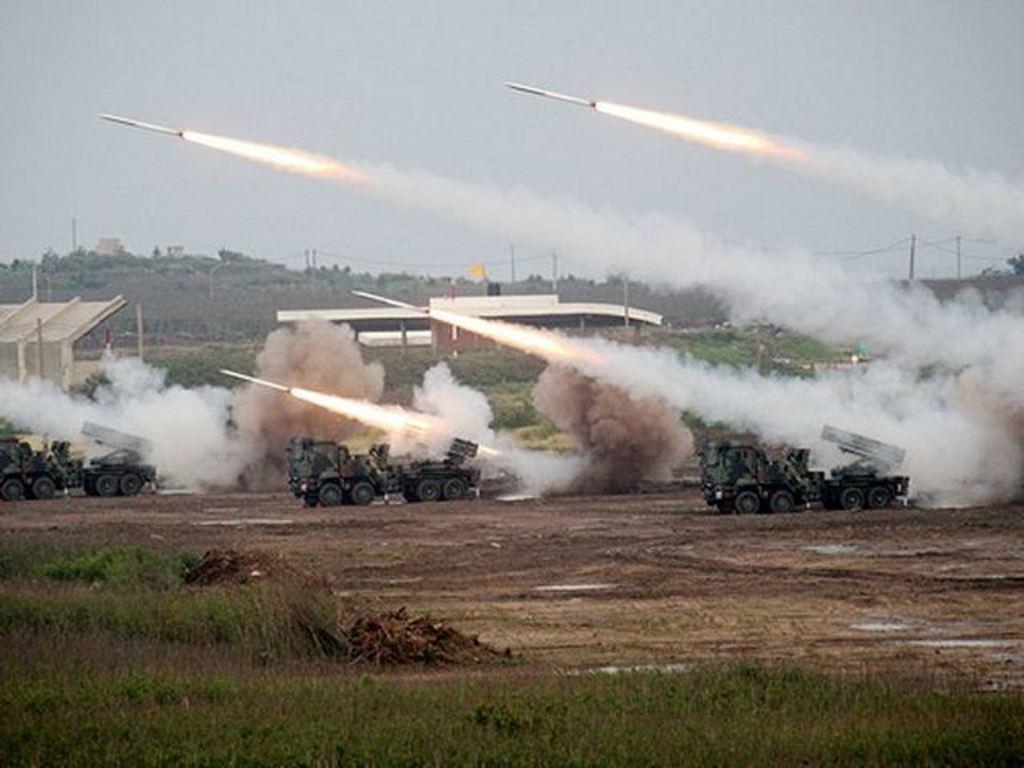In one or two sentences, can you explain what this image depicts? In this image we can see some trucks on the land. We can also see some jets with smoke flying in the sky. On the backside we can see a building, trees, pole with wires and the sky which looks cloudy. On the bottom of the image we can see some grass. 